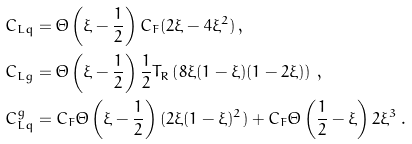Convert formula to latex. <formula><loc_0><loc_0><loc_500><loc_500>C _ { L q } & = \Theta \left ( \xi - \frac { 1 } { 2 } \right ) C _ { F } ( 2 \xi - 4 \xi ^ { 2 } ) \, , \\ C _ { L g } & = \Theta \left ( \xi - \frac { 1 } { 2 } \right ) \frac { 1 } { 2 } T _ { R } \left ( 8 \xi ( 1 - \xi ) ( 1 - 2 \xi ) \right ) \, , \\ C _ { L q } ^ { g } & = C _ { F } \Theta \left ( \xi - \frac { 1 } { 2 } \right ) ( 2 \xi ( 1 - \xi ) ^ { 2 } ) + C _ { F } \Theta \left ( \frac { 1 } { 2 } - \xi \right ) 2 \xi ^ { 3 } \, .</formula> 